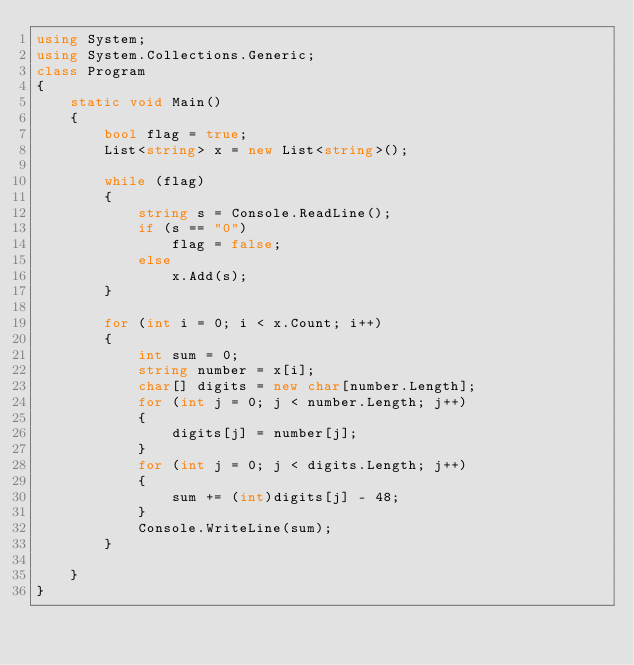<code> <loc_0><loc_0><loc_500><loc_500><_C#_>using System;
using System.Collections.Generic;
class Program
{
    static void Main()
    {
        bool flag = true;
        List<string> x = new List<string>();

        while (flag)
        {
            string s = Console.ReadLine();
            if (s == "0")
                flag = false;
            else
                x.Add(s);
        }

        for (int i = 0; i < x.Count; i++) 
        {
            int sum = 0;
            string number = x[i];
            char[] digits = new char[number.Length];
            for (int j = 0; j < number.Length; j++)
            {
                digits[j] = number[j];
            }
            for (int j = 0; j < digits.Length; j++)
            {
                sum += (int)digits[j] - 48;
            }
            Console.WriteLine(sum);
        }

    }
}</code> 